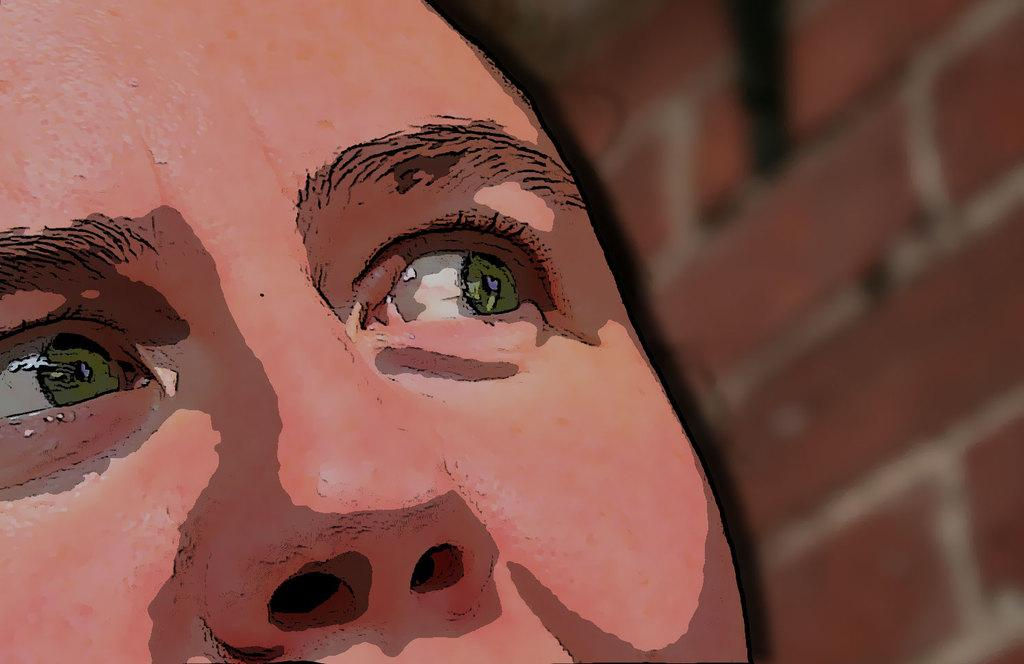What facial features are visible in the foreground of the image? There is a person's eye and nose in the foreground of the image. What type of structure can be seen on the right side of the image? There is a brick wall on the right side of the image. Reasoning: Let' Let's think step by step in order to produce the conversation. We start by identifying the main subjects in the image, which are the person's eye and nose in the foreground. Then, we describe the structure on the right side of the image, which is a brick wall. We avoid making any assumptions about the image and focus on the facts provided. Absurd Question/Answer: What type of chain can be seen hanging from the person's nose in the image? There is no chain present in the image; only the person's eye and nose are visible in the foreground. Can you tell me how many plantations are visible in the image? There are no plantations present in the image. 